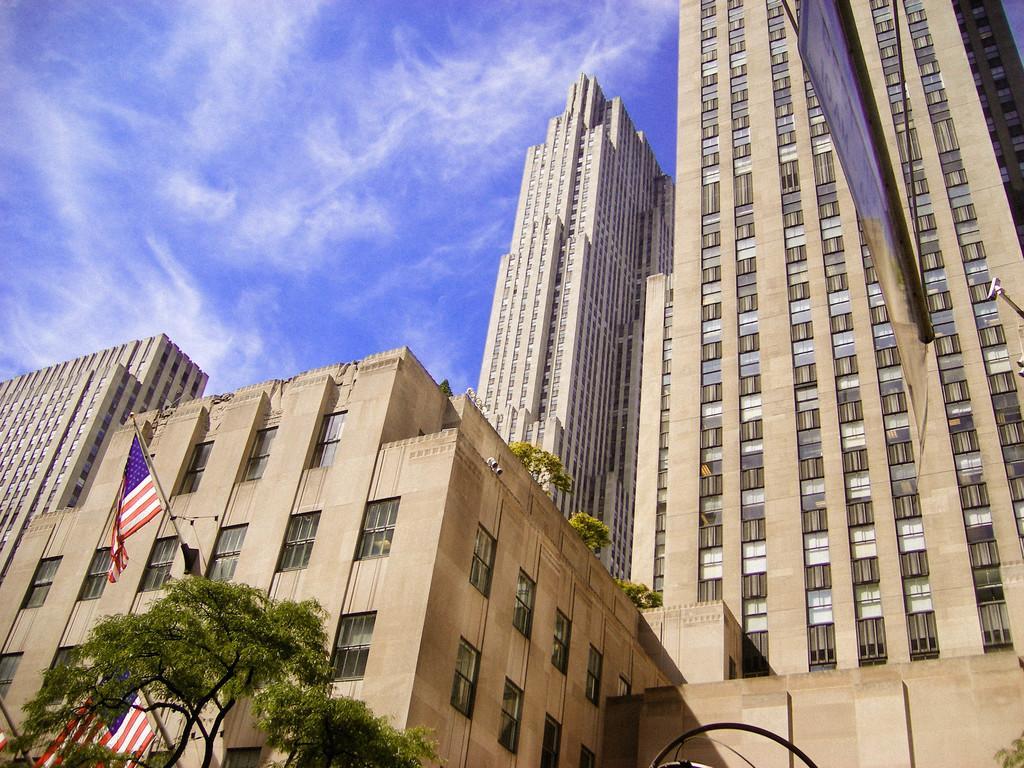How would you summarize this image in a sentence or two? In this image, in the middle there are buildings, flags, trees, windows, poster, sky and clouds. 